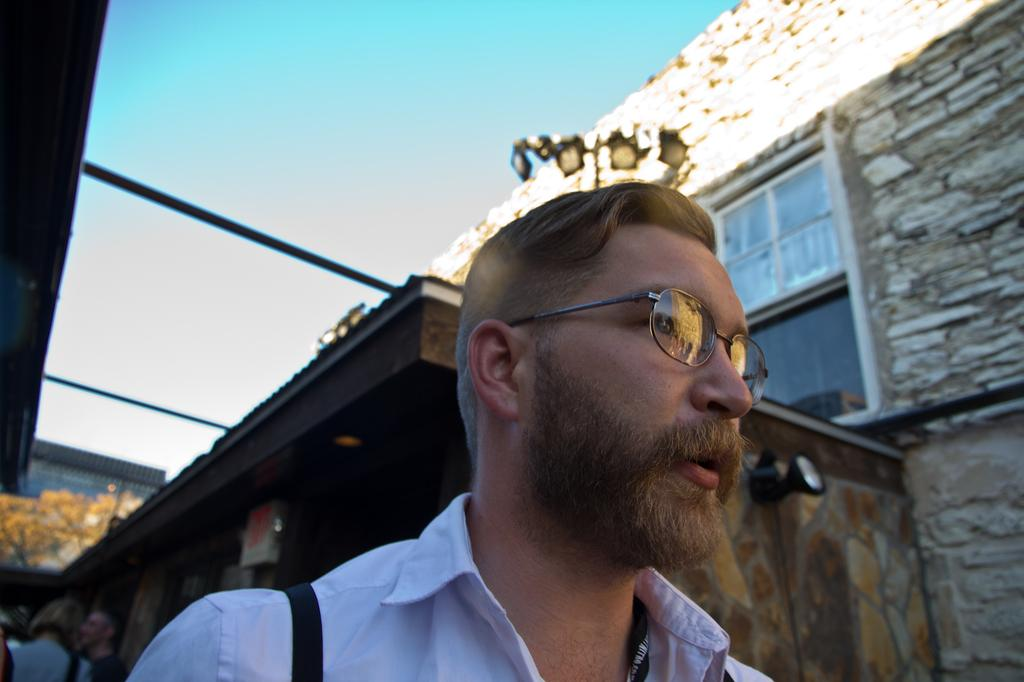What is the main subject of the image? There is a person in the image. Can you describe the person's appearance? The person is wearing spectacles. What can be seen in the background of the image? There are buildings, people, a camera, a window, and the sky visible in the background of the image. How many eggs are being blown by the person in the image? There are no eggs or blowing activity present in the image. 